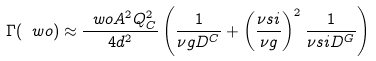<formula> <loc_0><loc_0><loc_500><loc_500>\Gamma ( \ w o ) \approx \frac { \ w o A ^ { 2 } Q _ { C } ^ { 2 } } { 4 d ^ { 2 } } \left ( \frac { 1 } { \nu g D ^ { C } } + \left ( \frac { \nu s i } { \nu g } \right ) ^ { 2 } \frac { 1 } { \nu s i D ^ { G } } \right )</formula> 